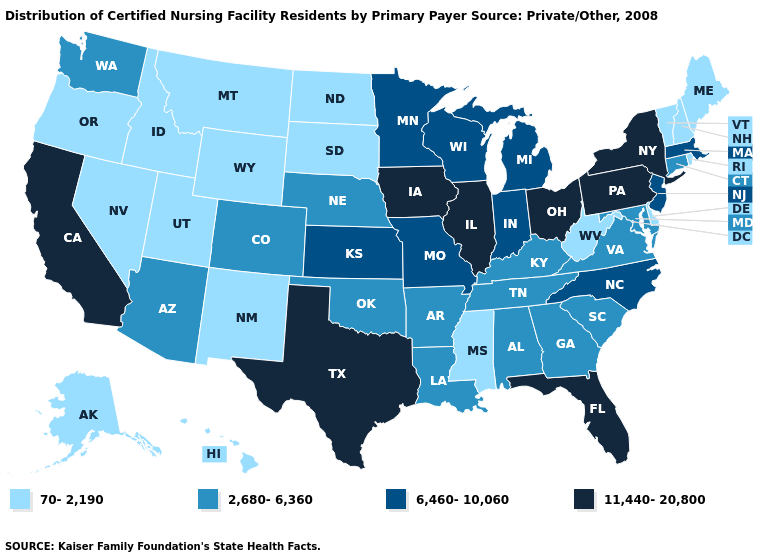Does Ohio have the highest value in the MidWest?
Keep it brief. Yes. What is the value of Nevada?
Keep it brief. 70-2,190. Name the states that have a value in the range 11,440-20,800?
Keep it brief. California, Florida, Illinois, Iowa, New York, Ohio, Pennsylvania, Texas. Name the states that have a value in the range 6,460-10,060?
Be succinct. Indiana, Kansas, Massachusetts, Michigan, Minnesota, Missouri, New Jersey, North Carolina, Wisconsin. Name the states that have a value in the range 70-2,190?
Be succinct. Alaska, Delaware, Hawaii, Idaho, Maine, Mississippi, Montana, Nevada, New Hampshire, New Mexico, North Dakota, Oregon, Rhode Island, South Dakota, Utah, Vermont, West Virginia, Wyoming. Does Maryland have a lower value than New Jersey?
Give a very brief answer. Yes. How many symbols are there in the legend?
Concise answer only. 4. Does Tennessee have the lowest value in the USA?
Concise answer only. No. Name the states that have a value in the range 6,460-10,060?
Keep it brief. Indiana, Kansas, Massachusetts, Michigan, Minnesota, Missouri, New Jersey, North Carolina, Wisconsin. What is the lowest value in the South?
Answer briefly. 70-2,190. Among the states that border California , does Oregon have the highest value?
Be succinct. No. Is the legend a continuous bar?
Be succinct. No. Is the legend a continuous bar?
Quick response, please. No. Among the states that border New Hampshire , does Maine have the lowest value?
Write a very short answer. Yes. 